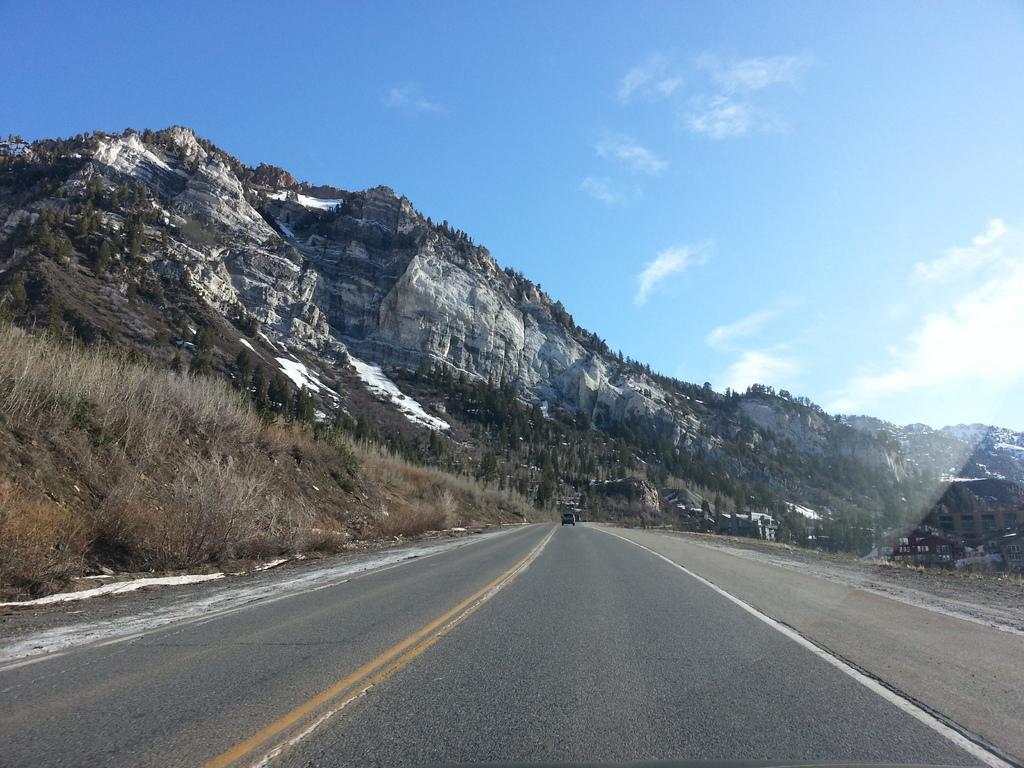Could you give a brief overview of what you see in this image? In the image there is a road and around the road there are mountains. 